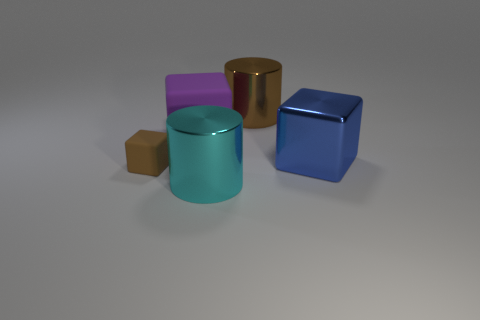The cyan object that is the same size as the blue cube is what shape?
Your response must be concise. Cylinder. What is the shape of the metallic thing that is the same color as the small rubber thing?
Your answer should be very brief. Cylinder. There is a metal cylinder that is behind the small object; does it have the same color as the tiny matte thing?
Ensure brevity in your answer.  Yes. What number of things are matte objects that are on the right side of the small brown matte cube or shiny things left of the big brown cylinder?
Keep it short and to the point. 2. There is a big brown object that is the same material as the big cyan cylinder; what is its shape?
Your response must be concise. Cylinder. Is there any other thing of the same color as the shiny cube?
Offer a very short reply. No. There is a small brown thing that is the same shape as the purple object; what is its material?
Your response must be concise. Rubber. What number of other things are the same size as the brown rubber cube?
Your response must be concise. 0. What is the material of the big brown cylinder?
Offer a very short reply. Metal. Are there more big cubes that are on the left side of the big cyan shiny cylinder than tiny blue matte blocks?
Provide a succinct answer. Yes. 